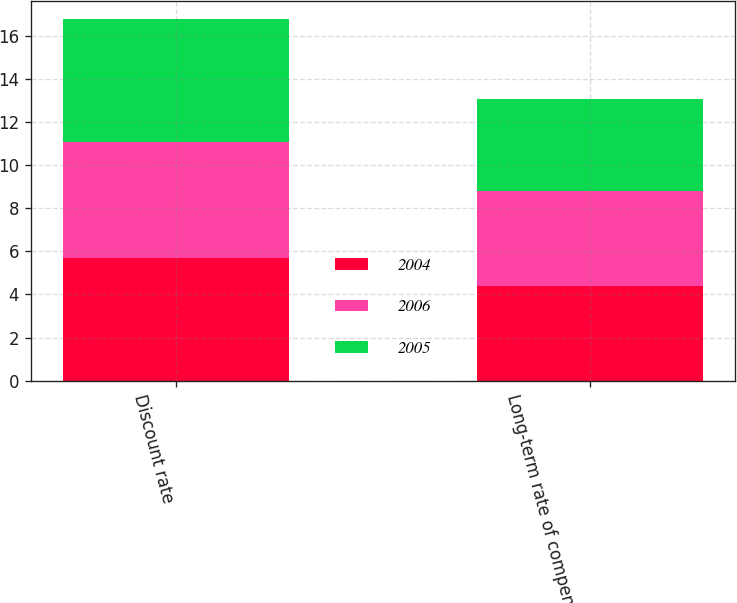Convert chart to OTSL. <chart><loc_0><loc_0><loc_500><loc_500><stacked_bar_chart><ecel><fcel>Discount rate<fcel>Long-term rate of compensation<nl><fcel>2004<fcel>5.7<fcel>4.4<nl><fcel>2006<fcel>5.4<fcel>4.4<nl><fcel>2005<fcel>5.7<fcel>4.3<nl></chart> 